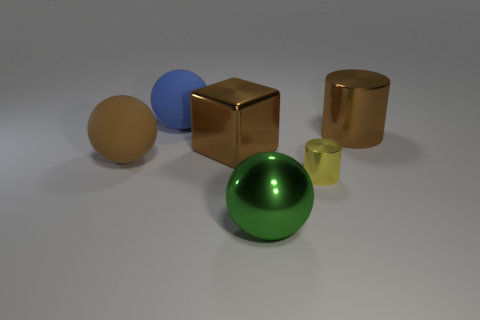Add 2 balls. How many objects exist? 8 Subtract all cylinders. How many objects are left? 4 Add 5 large brown balls. How many large brown balls exist? 6 Subtract 1 brown cylinders. How many objects are left? 5 Subtract all big blue objects. Subtract all brown metallic cubes. How many objects are left? 4 Add 1 brown metallic cylinders. How many brown metallic cylinders are left? 2 